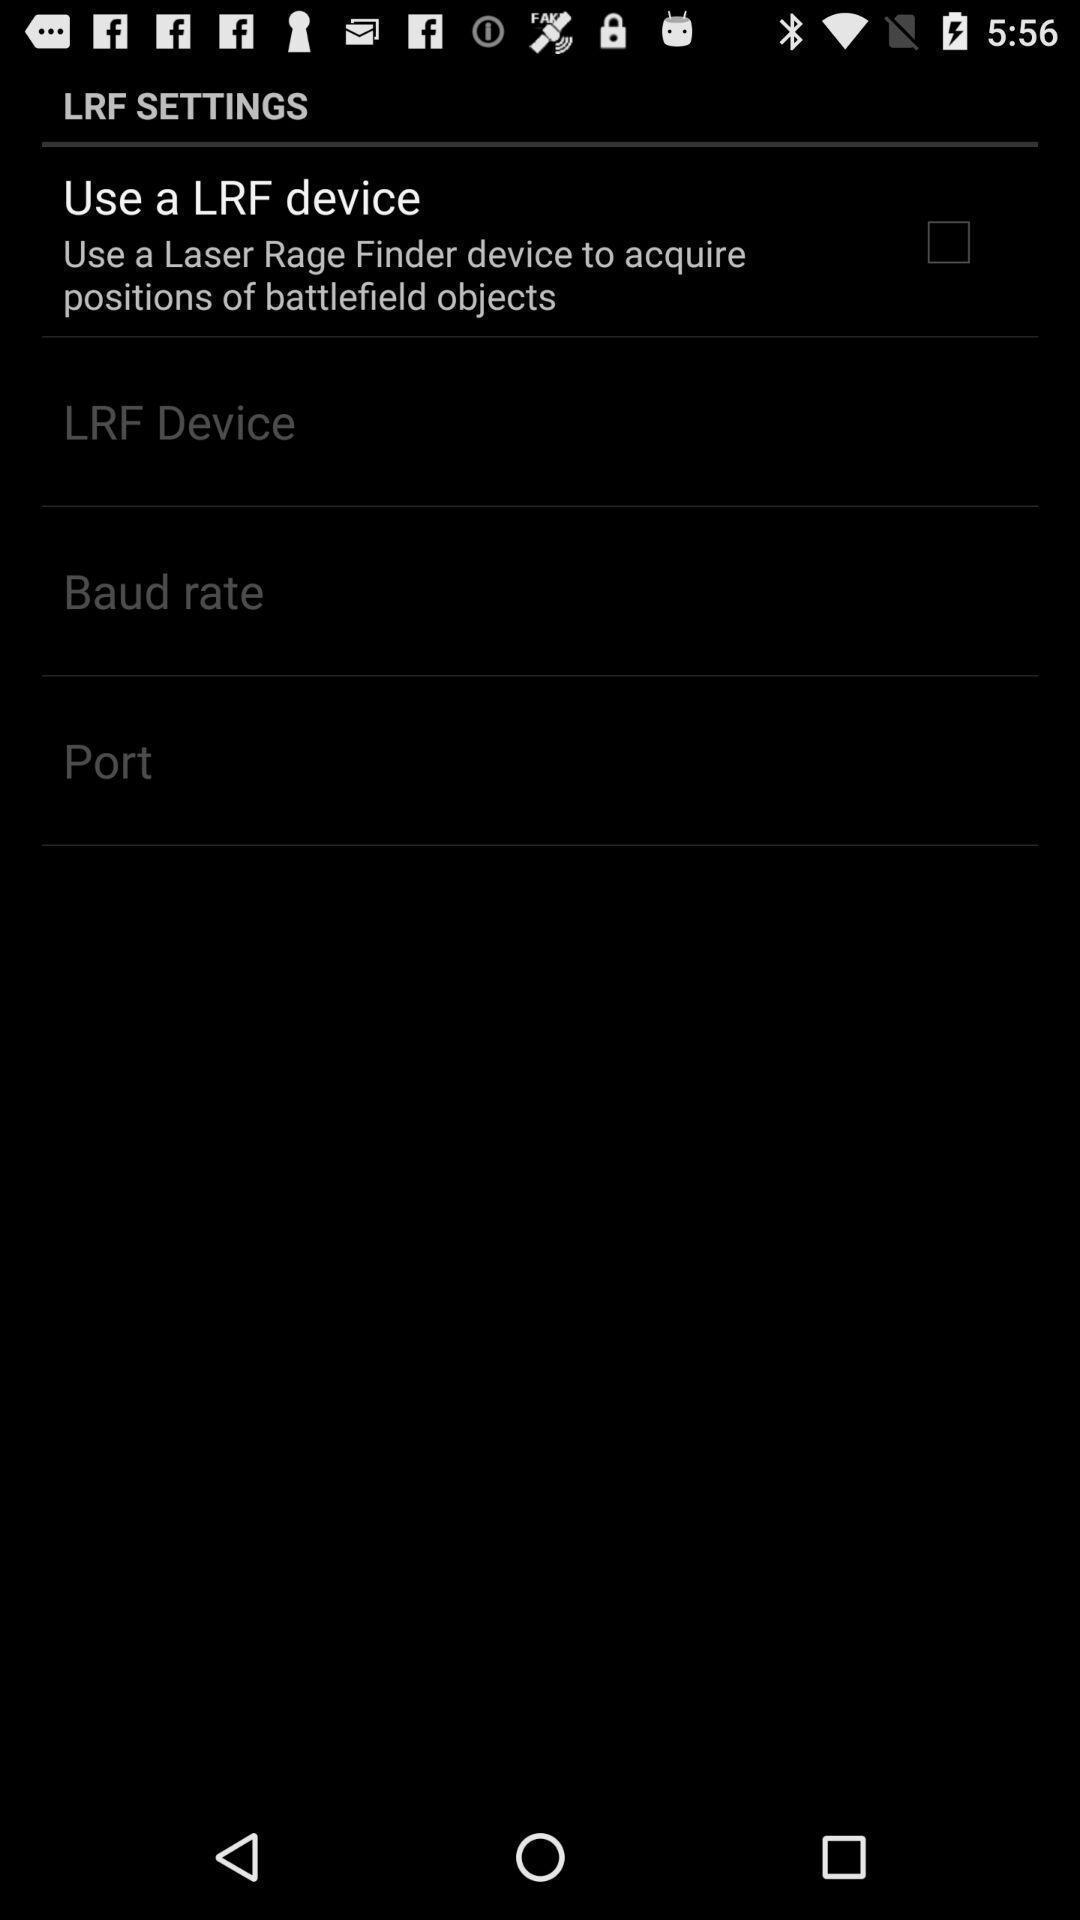Explain what's happening in this screen capture. Screen displaying the screen page. 